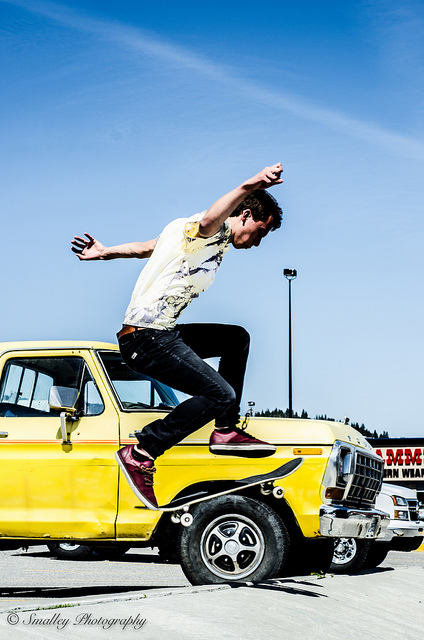Read all the text in this image. MM C Smalley Photography 